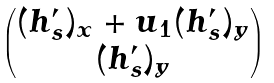<formula> <loc_0><loc_0><loc_500><loc_500>\begin{pmatrix} ( h ^ { \prime } _ { s } ) _ { x } + u _ { 1 } ( h ^ { \prime } _ { s } ) _ { y } \\ ( h ^ { \prime } _ { s } ) _ { y } \end{pmatrix}</formula> 